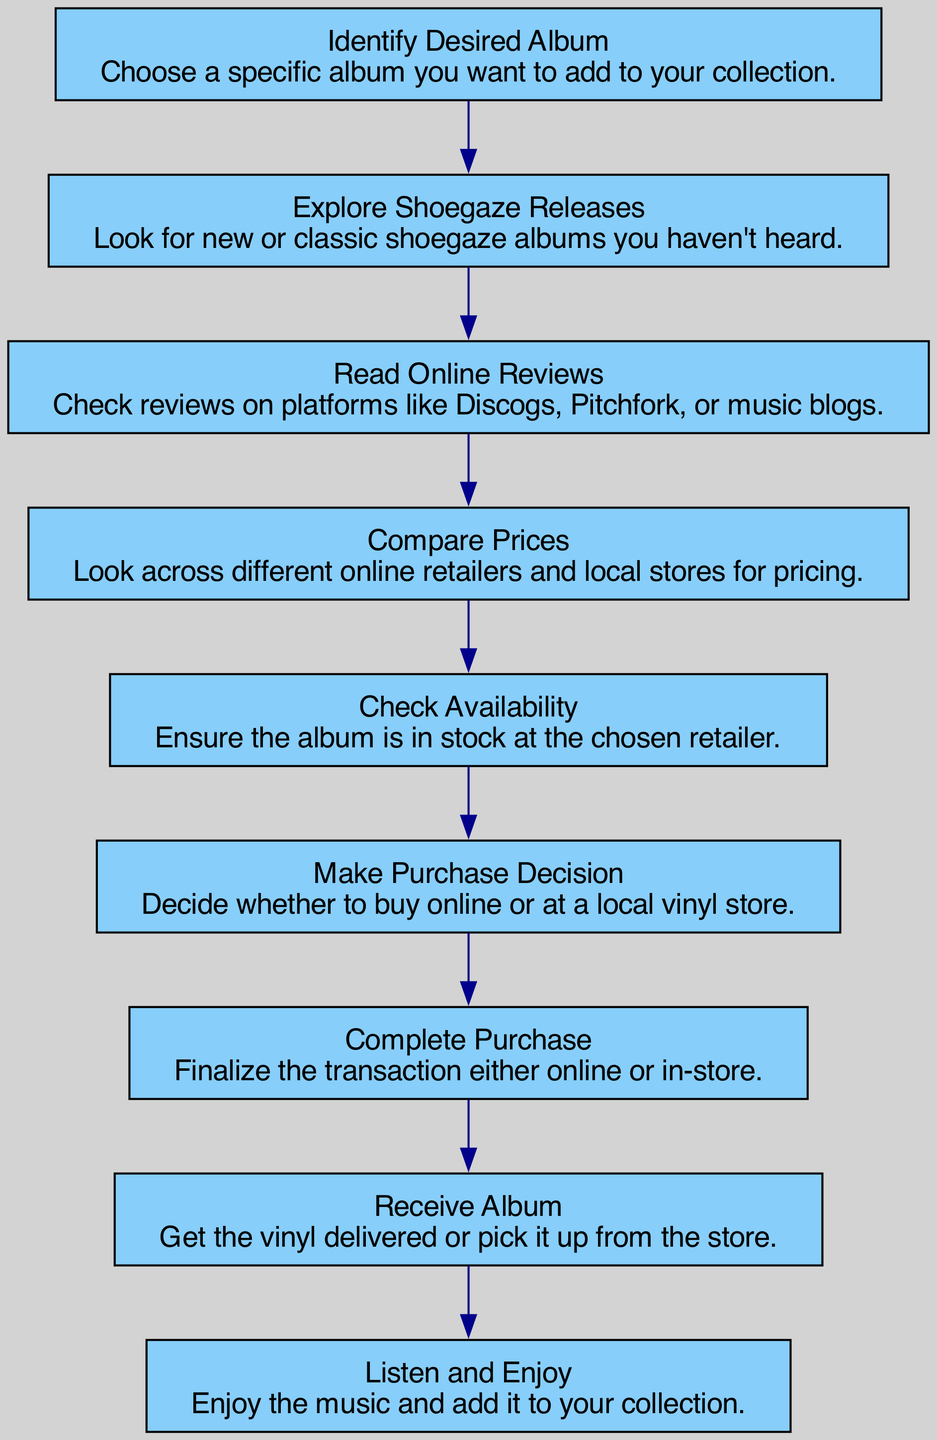What is the first step in the process? The first step in the process, as indicated in the diagram, is "Identify Desired Album." This is the starting point for any vinyl collector looking to expand their collection.
Answer: Identify Desired Album How many main steps are there in the vinyl selection process? By counting the nodes in the diagram, we see there are a total of eight main steps listed, starting from identifying the desired album and ending with listening and enjoying the album.
Answer: Eight What is the last step in the process? The final step in the process is "Listen and Enjoy." This indicates completing the purchase and then relishing the new vinyl addition in the collection.
Answer: Listen and Enjoy Which step comes after checking availability? After "Check Availability," the next step in the flow is "Make Purchase Decision." This shows the decision-making point after confirming the album's stock.
Answer: Make Purchase Decision What relationship exists between "Read Online Reviews" and "Compare Prices"? "Read Online Reviews" comes before "Compare Prices," indicating that the decision to compare prices is informed by the insights gained from reviews. This shows the flow of information leading into pricing decisions.
Answer: Read Online Reviews → Compare Prices What is the main purpose of the "Explore Shoegaze Releases" step? The purpose of this step is to help a passionate collector discover new or classic shoegaze albums, enriching their knowledge and options for vinyl acquisition.
Answer: Discover new or classic albums How do you proceed after "Complete Purchase"? After you "Complete Purchase," the next step is "Receive Album," highlighting the process of obtaining the vinyl after the transaction is finalized.
Answer: Receive Album Is "Compare Prices" before or after "Read Online Reviews"? "Compare Prices" is after "Read Online Reviews." This order suggests that collectors should evaluate reviews before moving on to price comparisons across retailers.
Answer: After What activity follows "Check Availability"? The activity that follows "Check Availability" is "Make Purchase Decision," which directs the collector's next course of action based on stock status.
Answer: Make Purchase Decision 